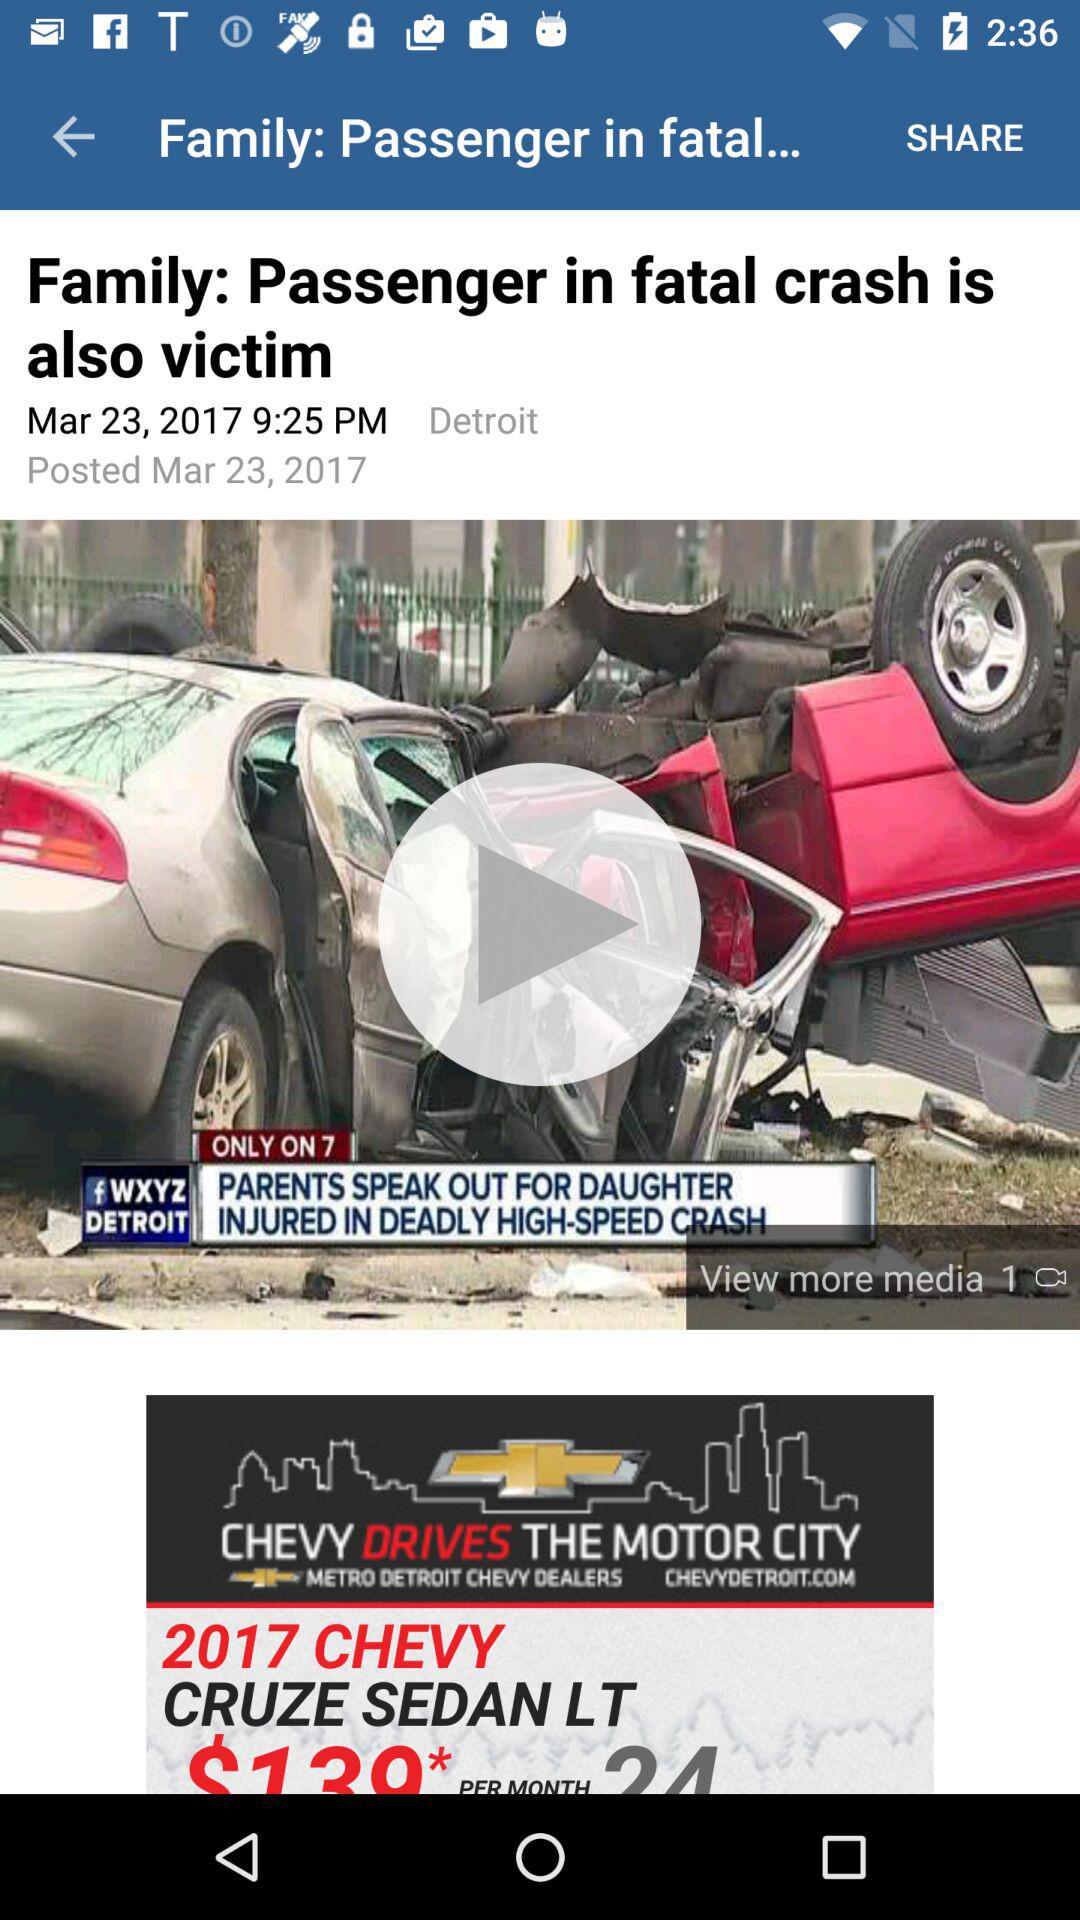What is the date and time the news was posted? The news was posted on March 23, 2017 at 9:25 PM. 